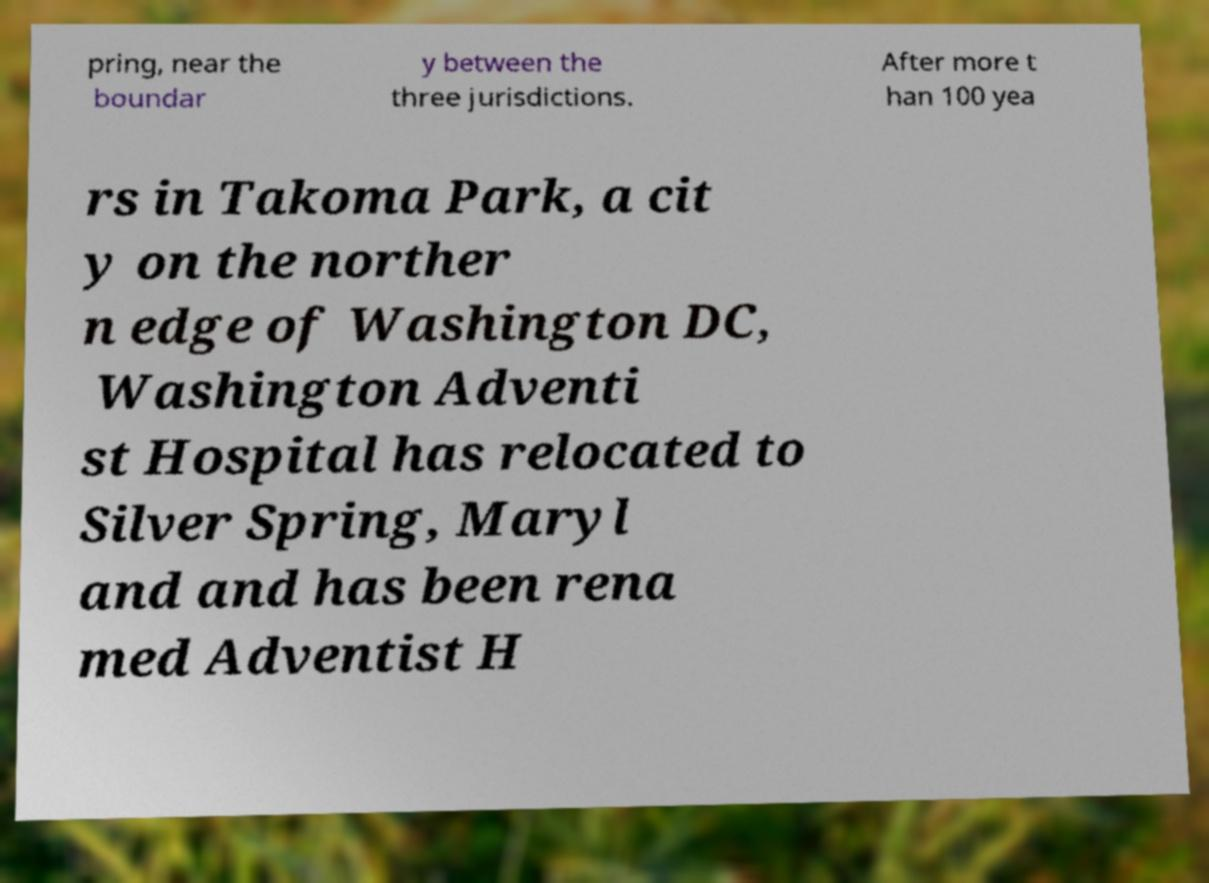Can you read and provide the text displayed in the image?This photo seems to have some interesting text. Can you extract and type it out for me? pring, near the boundar y between the three jurisdictions. After more t han 100 yea rs in Takoma Park, a cit y on the norther n edge of Washington DC, Washington Adventi st Hospital has relocated to Silver Spring, Maryl and and has been rena med Adventist H 